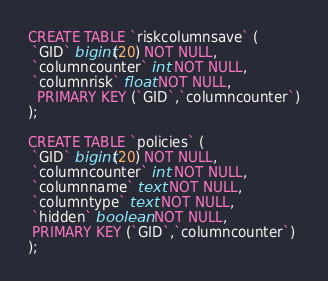<code> <loc_0><loc_0><loc_500><loc_500><_SQL_>
CREATE TABLE `riskcolumnsave` ( 
 `GID` bigint(20) NOT NULL,
 `columncounter` int NOT NULL,
 `columnrisk` float NOT NULL,
  PRIMARY KEY (`GID`,`columncounter`)
);

CREATE TABLE `policies` ( 
 `GID` bigint(20) NOT NULL,
 `columncounter` int NOT NULL,
 `columnname` text NOT NULL,
 `columntype` text NOT NULL,
 `hidden` boolean NOT NULL,	
 PRIMARY KEY (`GID`,`columncounter`)
);

</code> 